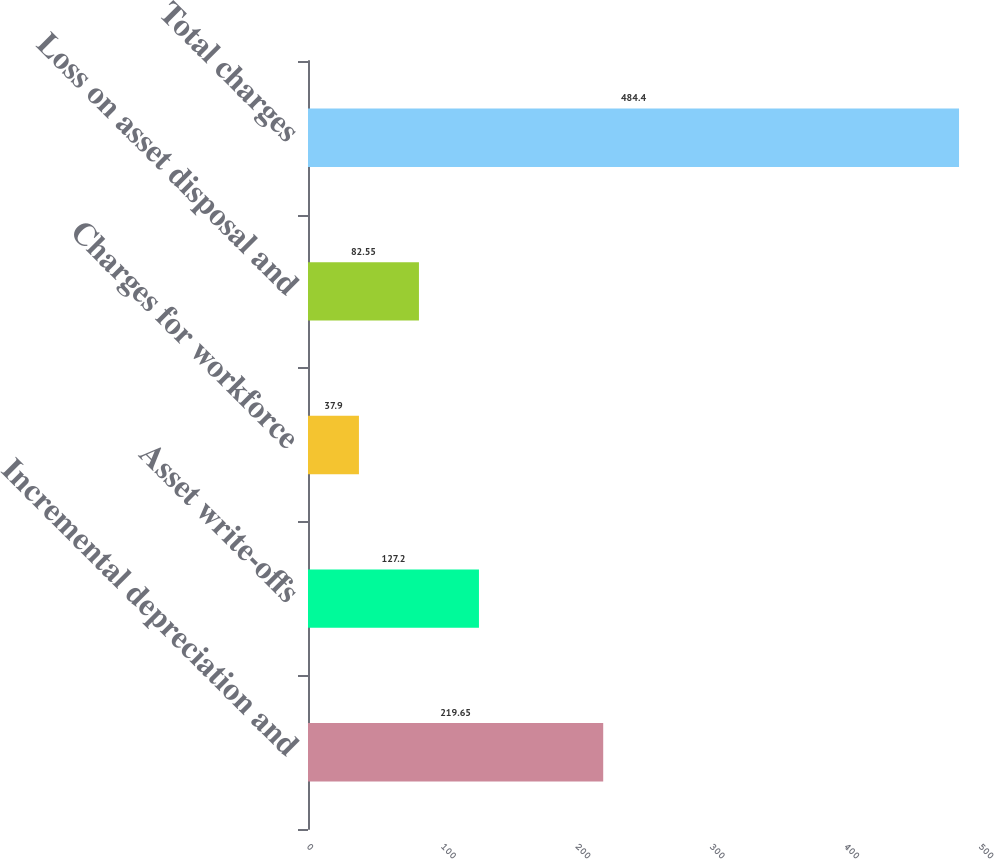Convert chart to OTSL. <chart><loc_0><loc_0><loc_500><loc_500><bar_chart><fcel>Incremental depreciation and<fcel>Asset write-offs<fcel>Charges for workforce<fcel>Loss on asset disposal and<fcel>Total charges<nl><fcel>219.65<fcel>127.2<fcel>37.9<fcel>82.55<fcel>484.4<nl></chart> 